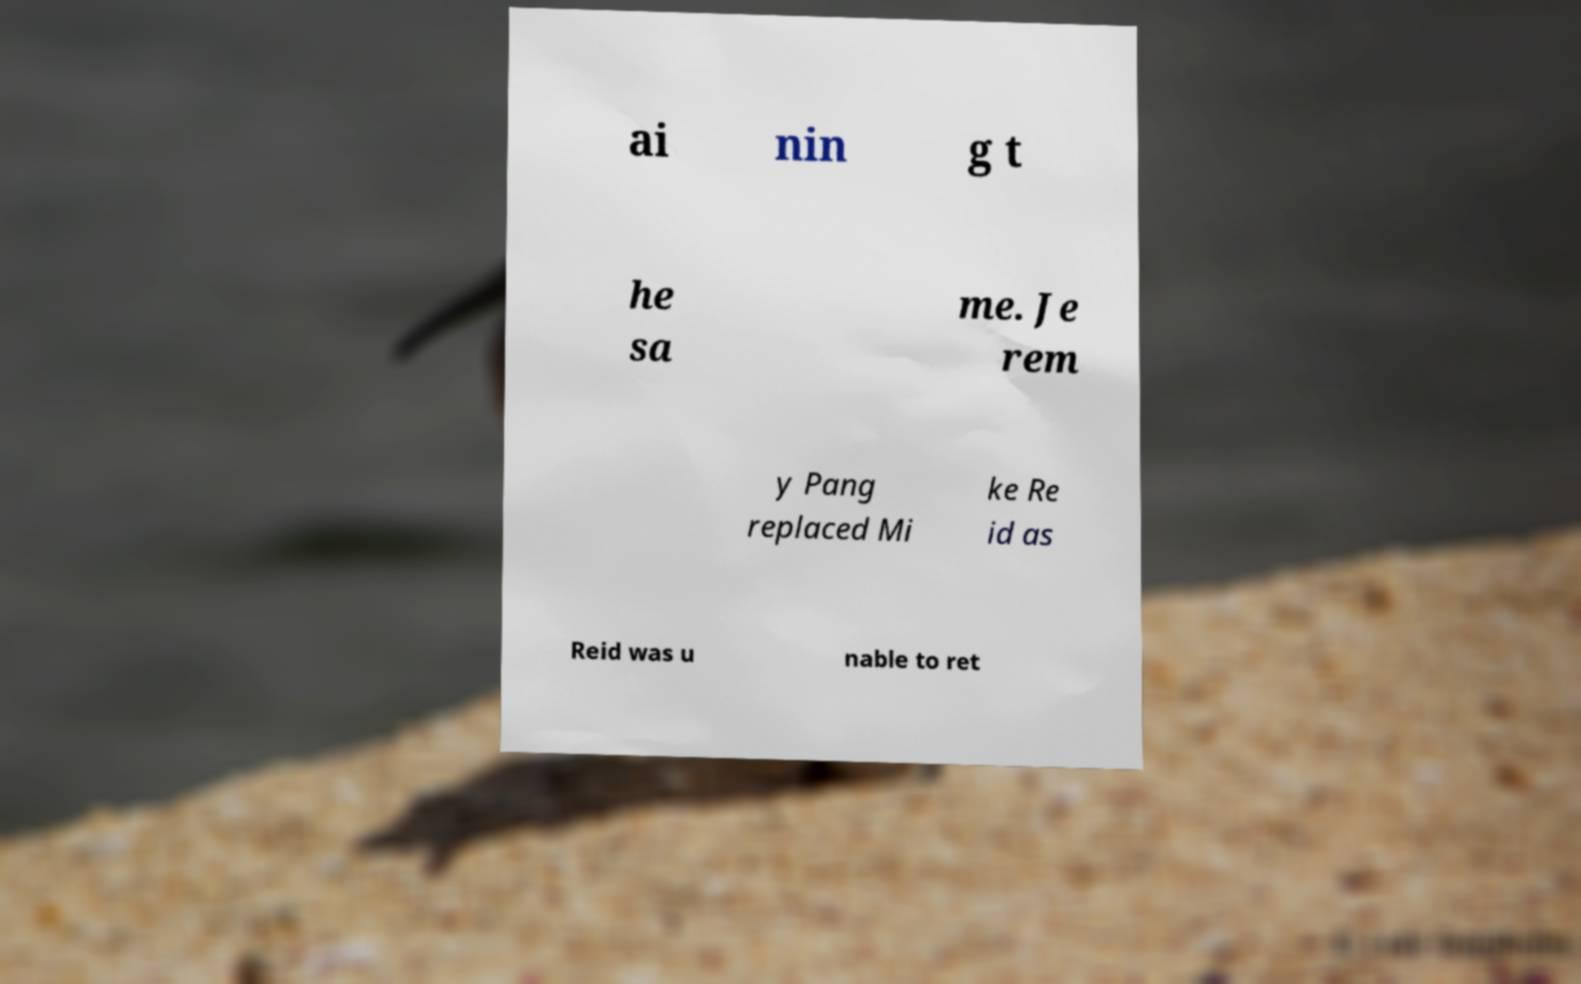Can you read and provide the text displayed in the image?This photo seems to have some interesting text. Can you extract and type it out for me? ai nin g t he sa me. Je rem y Pang replaced Mi ke Re id as Reid was u nable to ret 